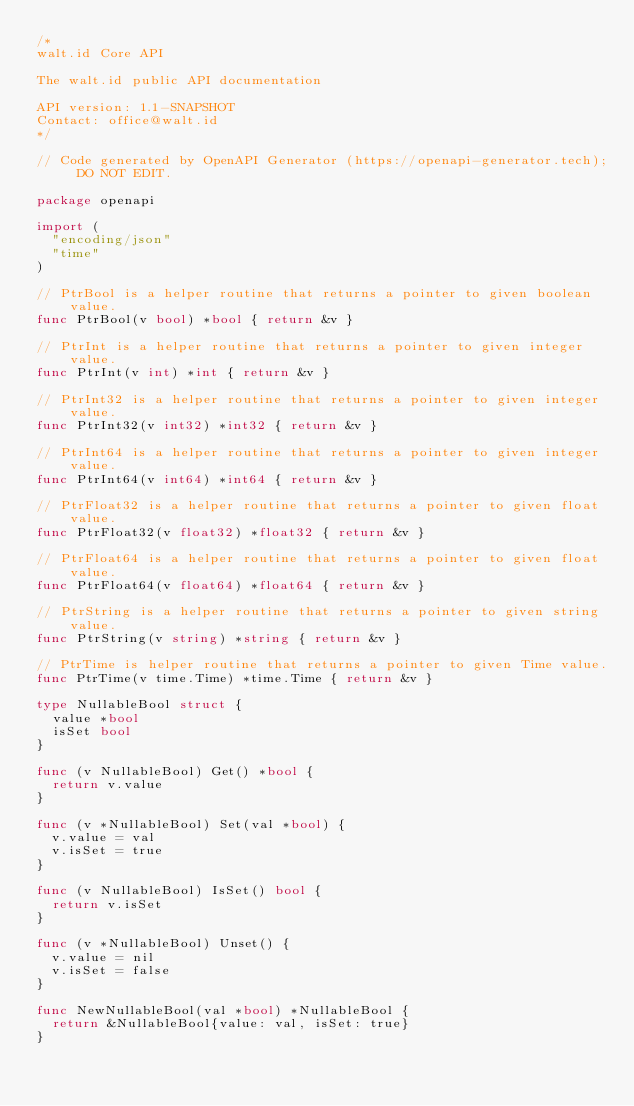Convert code to text. <code><loc_0><loc_0><loc_500><loc_500><_Go_>/*
walt.id Core API

The walt.id public API documentation

API version: 1.1-SNAPSHOT
Contact: office@walt.id
*/

// Code generated by OpenAPI Generator (https://openapi-generator.tech); DO NOT EDIT.

package openapi

import (
	"encoding/json"
	"time"
)

// PtrBool is a helper routine that returns a pointer to given boolean value.
func PtrBool(v bool) *bool { return &v }

// PtrInt is a helper routine that returns a pointer to given integer value.
func PtrInt(v int) *int { return &v }

// PtrInt32 is a helper routine that returns a pointer to given integer value.
func PtrInt32(v int32) *int32 { return &v }

// PtrInt64 is a helper routine that returns a pointer to given integer value.
func PtrInt64(v int64) *int64 { return &v }

// PtrFloat32 is a helper routine that returns a pointer to given float value.
func PtrFloat32(v float32) *float32 { return &v }

// PtrFloat64 is a helper routine that returns a pointer to given float value.
func PtrFloat64(v float64) *float64 { return &v }

// PtrString is a helper routine that returns a pointer to given string value.
func PtrString(v string) *string { return &v }

// PtrTime is helper routine that returns a pointer to given Time value.
func PtrTime(v time.Time) *time.Time { return &v }

type NullableBool struct {
	value *bool
	isSet bool
}

func (v NullableBool) Get() *bool {
	return v.value
}

func (v *NullableBool) Set(val *bool) {
	v.value = val
	v.isSet = true
}

func (v NullableBool) IsSet() bool {
	return v.isSet
}

func (v *NullableBool) Unset() {
	v.value = nil
	v.isSet = false
}

func NewNullableBool(val *bool) *NullableBool {
	return &NullableBool{value: val, isSet: true}
}
</code> 